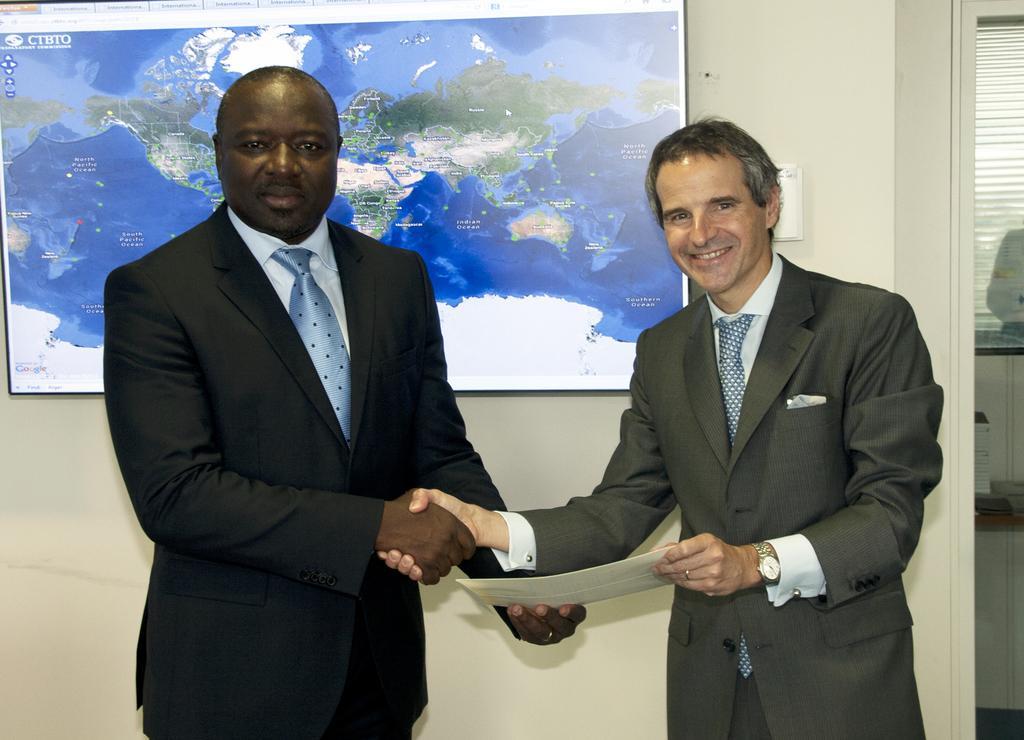How would you summarize this image in a sentence or two? In this image I can see two men are standing and giving shake hands. These people are wearing white color shirts, ties and suits. These people are smiling. In the background I can see a wall which has a TV attached to it. On the screen I can see a map. 